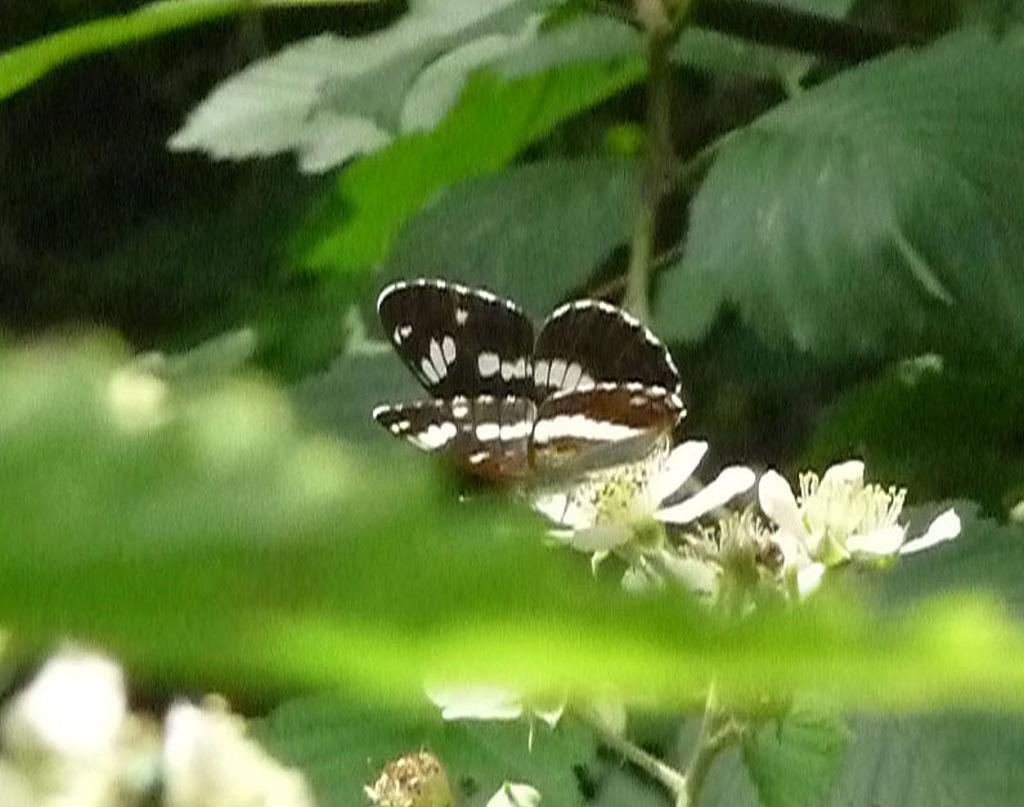What is the main subject of the image? There is a butterfly on a flower in the image. What can be seen in the background of the image? There are leaves and flowers in the background of the image. What type of yam is being used to help the sail in the image? There is no yam or sail present in the image; it features a butterfly on a flower with leaves and flowers in the background. 